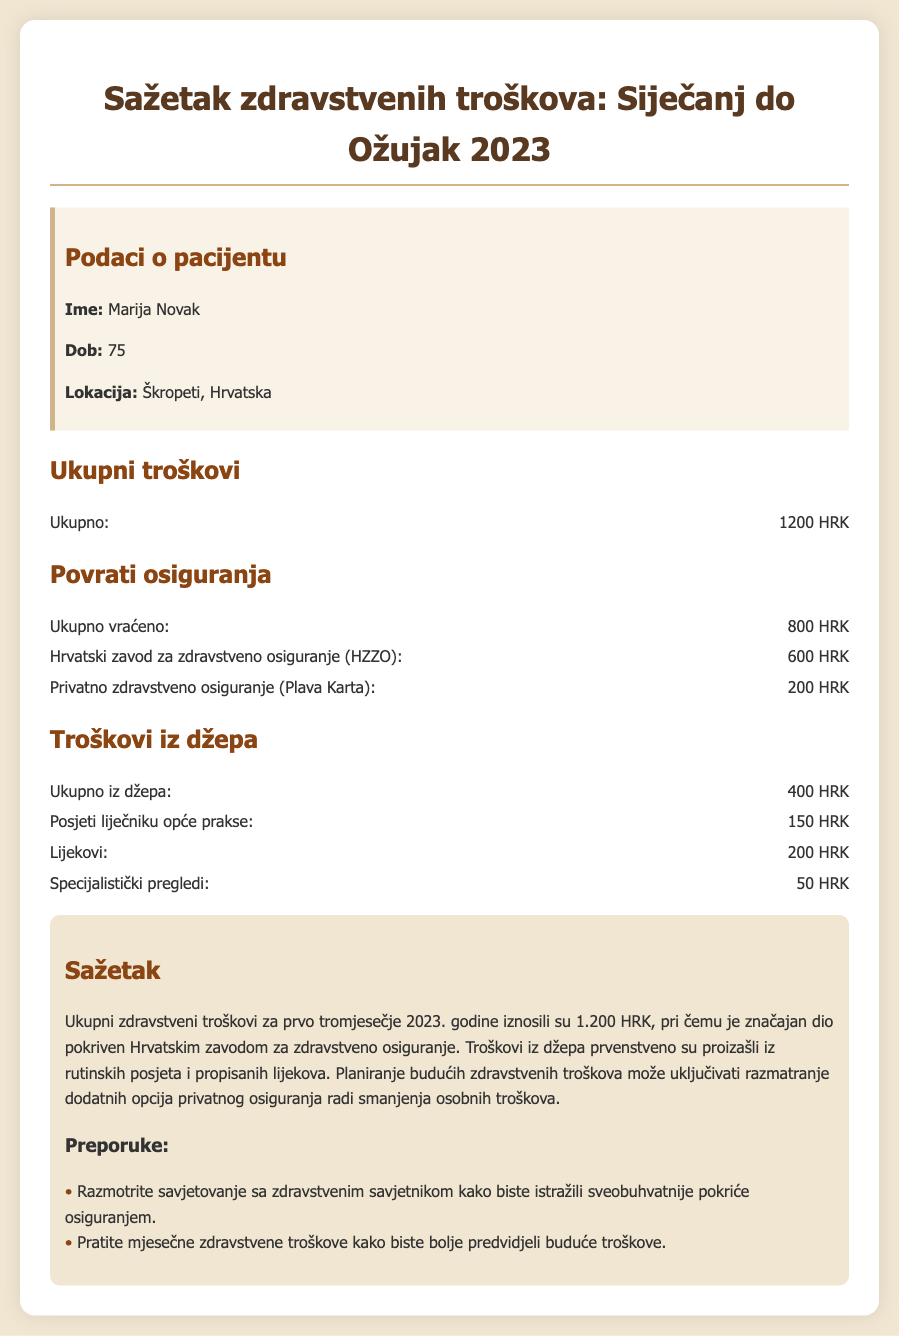What is the total healthcare expense? The total healthcare expense is provided in the "Ukupno" section of the document, which states it is 1200 HRK.
Answer: 1200 HRK How much was reimbursed by HZZO? The document details the reimbursement amounts, showing that the Hrvatski zavod za zdravstveno osiguranje (HZZO) reimbursed 600 HRK.
Answer: 600 HRK What was the total out-of-pocket cost? The total out-of-pocket cost is mentioned in the "Ukupno iz džepa" section, which specifies it as 400 HRK.
Answer: 400 HRK Which insurance provided the least reimbursement? A comparison of the reimbursements shows that the private health insurance (Plava Karta) provided the least, with a reimbursement of 200 HRK.
Answer: 200 HRK What are the primary out-of-pocket expenses? The document lists the out-of-pocket expenses for visits and medications, which primarily include visits to a general practitioner, medication, and specialist examinations.
Answer: Posjeti liječniku opće prakse, Lijekovi, Specijalistički pregledi How much was spent on medications? The document specifically states the out-of-pocket spending on medications is 200 HRK.
Answer: 200 HRK What recommendations were provided for future healthcare costs? The summary section provides recommendations for future healthcare costs, which include consulting a health advisor and tracking monthly healthcare expenses.
Answer: Savjetovanje sa zdravstvenim savjetnikom, Praćenje mjesečnih zdravstvenih troškova What is the patient's age? The patient's age is explicitly stated in the patient information section, which shows her age as 75.
Answer: 75 How much was reimbursed by private health insurance? The document reveals that the reimbursement from private health insurance (Plava Karta) amounts to 200 HRK.
Answer: 200 HRK 